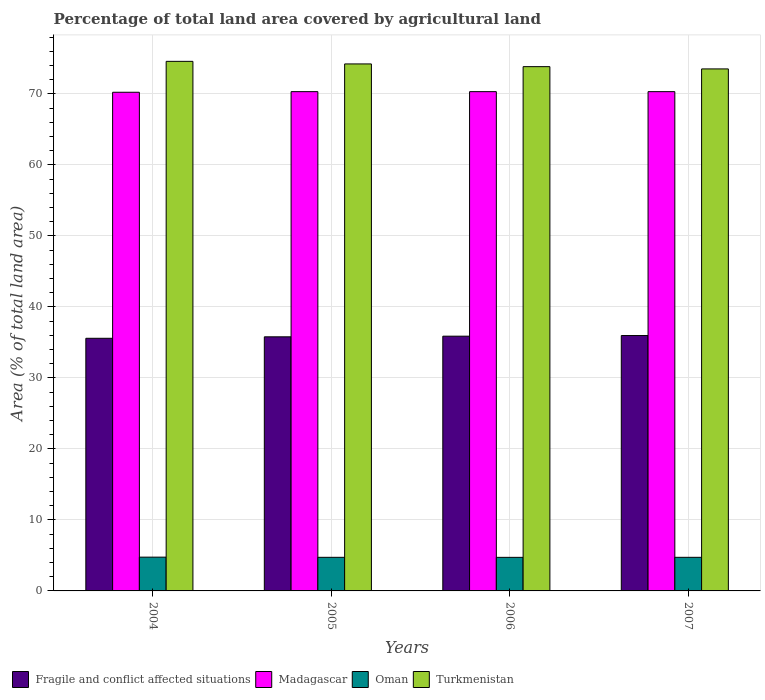How many different coloured bars are there?
Give a very brief answer. 4. How many groups of bars are there?
Keep it short and to the point. 4. Are the number of bars per tick equal to the number of legend labels?
Your response must be concise. Yes. How many bars are there on the 3rd tick from the right?
Offer a very short reply. 4. What is the label of the 2nd group of bars from the left?
Keep it short and to the point. 2005. In how many cases, is the number of bars for a given year not equal to the number of legend labels?
Ensure brevity in your answer.  0. What is the percentage of agricultural land in Oman in 2006?
Offer a terse response. 4.73. Across all years, what is the maximum percentage of agricultural land in Fragile and conflict affected situations?
Keep it short and to the point. 35.97. Across all years, what is the minimum percentage of agricultural land in Fragile and conflict affected situations?
Give a very brief answer. 35.58. In which year was the percentage of agricultural land in Madagascar maximum?
Your answer should be compact. 2005. In which year was the percentage of agricultural land in Turkmenistan minimum?
Provide a short and direct response. 2007. What is the total percentage of agricultural land in Oman in the graph?
Give a very brief answer. 18.95. What is the difference between the percentage of agricultural land in Madagascar in 2006 and that in 2007?
Your answer should be very brief. 0. What is the difference between the percentage of agricultural land in Fragile and conflict affected situations in 2005 and the percentage of agricultural land in Oman in 2004?
Your answer should be very brief. 31.03. What is the average percentage of agricultural land in Madagascar per year?
Offer a terse response. 70.3. In the year 2004, what is the difference between the percentage of agricultural land in Madagascar and percentage of agricultural land in Turkmenistan?
Make the answer very short. -4.35. What is the ratio of the percentage of agricultural land in Oman in 2004 to that in 2005?
Your response must be concise. 1. Is the percentage of agricultural land in Madagascar in 2004 less than that in 2005?
Keep it short and to the point. Yes. Is the difference between the percentage of agricultural land in Madagascar in 2005 and 2007 greater than the difference between the percentage of agricultural land in Turkmenistan in 2005 and 2007?
Your answer should be compact. No. What is the difference between the highest and the second highest percentage of agricultural land in Oman?
Make the answer very short. 0.02. What is the difference between the highest and the lowest percentage of agricultural land in Oman?
Provide a short and direct response. 0.03. In how many years, is the percentage of agricultural land in Madagascar greater than the average percentage of agricultural land in Madagascar taken over all years?
Provide a short and direct response. 3. Is the sum of the percentage of agricultural land in Turkmenistan in 2005 and 2006 greater than the maximum percentage of agricultural land in Madagascar across all years?
Give a very brief answer. Yes. What does the 3rd bar from the left in 2004 represents?
Offer a very short reply. Oman. What does the 3rd bar from the right in 2007 represents?
Your answer should be very brief. Madagascar. How many bars are there?
Keep it short and to the point. 16. Are all the bars in the graph horizontal?
Your answer should be compact. No. How many years are there in the graph?
Ensure brevity in your answer.  4. What is the difference between two consecutive major ticks on the Y-axis?
Ensure brevity in your answer.  10. Are the values on the major ticks of Y-axis written in scientific E-notation?
Make the answer very short. No. How are the legend labels stacked?
Keep it short and to the point. Horizontal. What is the title of the graph?
Give a very brief answer. Percentage of total land area covered by agricultural land. What is the label or title of the Y-axis?
Provide a succinct answer. Area (% of total land area). What is the Area (% of total land area) of Fragile and conflict affected situations in 2004?
Provide a succinct answer. 35.58. What is the Area (% of total land area) in Madagascar in 2004?
Your answer should be very brief. 70.23. What is the Area (% of total land area) of Oman in 2004?
Offer a terse response. 4.76. What is the Area (% of total land area) in Turkmenistan in 2004?
Your response must be concise. 74.59. What is the Area (% of total land area) of Fragile and conflict affected situations in 2005?
Give a very brief answer. 35.79. What is the Area (% of total land area) in Madagascar in 2005?
Keep it short and to the point. 70.32. What is the Area (% of total land area) in Oman in 2005?
Give a very brief answer. 4.73. What is the Area (% of total land area) of Turkmenistan in 2005?
Provide a succinct answer. 74.22. What is the Area (% of total land area) in Fragile and conflict affected situations in 2006?
Provide a short and direct response. 35.88. What is the Area (% of total land area) of Madagascar in 2006?
Make the answer very short. 70.32. What is the Area (% of total land area) of Oman in 2006?
Provide a succinct answer. 4.73. What is the Area (% of total land area) of Turkmenistan in 2006?
Give a very brief answer. 73.84. What is the Area (% of total land area) in Fragile and conflict affected situations in 2007?
Your answer should be compact. 35.97. What is the Area (% of total land area) of Madagascar in 2007?
Your answer should be very brief. 70.32. What is the Area (% of total land area) in Oman in 2007?
Keep it short and to the point. 4.73. What is the Area (% of total land area) in Turkmenistan in 2007?
Make the answer very short. 73.52. Across all years, what is the maximum Area (% of total land area) in Fragile and conflict affected situations?
Offer a very short reply. 35.97. Across all years, what is the maximum Area (% of total land area) of Madagascar?
Ensure brevity in your answer.  70.32. Across all years, what is the maximum Area (% of total land area) in Oman?
Give a very brief answer. 4.76. Across all years, what is the maximum Area (% of total land area) in Turkmenistan?
Keep it short and to the point. 74.59. Across all years, what is the minimum Area (% of total land area) in Fragile and conflict affected situations?
Ensure brevity in your answer.  35.58. Across all years, what is the minimum Area (% of total land area) in Madagascar?
Provide a succinct answer. 70.23. Across all years, what is the minimum Area (% of total land area) of Oman?
Provide a succinct answer. 4.73. Across all years, what is the minimum Area (% of total land area) in Turkmenistan?
Ensure brevity in your answer.  73.52. What is the total Area (% of total land area) in Fragile and conflict affected situations in the graph?
Your answer should be compact. 143.22. What is the total Area (% of total land area) in Madagascar in the graph?
Your answer should be very brief. 281.19. What is the total Area (% of total land area) of Oman in the graph?
Provide a short and direct response. 18.95. What is the total Area (% of total land area) of Turkmenistan in the graph?
Offer a very short reply. 296.17. What is the difference between the Area (% of total land area) in Fragile and conflict affected situations in 2004 and that in 2005?
Provide a short and direct response. -0.21. What is the difference between the Area (% of total land area) of Madagascar in 2004 and that in 2005?
Ensure brevity in your answer.  -0.09. What is the difference between the Area (% of total land area) in Oman in 2004 and that in 2005?
Give a very brief answer. 0.02. What is the difference between the Area (% of total land area) in Turkmenistan in 2004 and that in 2005?
Your response must be concise. 0.36. What is the difference between the Area (% of total land area) in Fragile and conflict affected situations in 2004 and that in 2006?
Provide a short and direct response. -0.3. What is the difference between the Area (% of total land area) in Madagascar in 2004 and that in 2006?
Ensure brevity in your answer.  -0.09. What is the difference between the Area (% of total land area) in Oman in 2004 and that in 2006?
Provide a short and direct response. 0.03. What is the difference between the Area (% of total land area) of Turkmenistan in 2004 and that in 2006?
Keep it short and to the point. 0.74. What is the difference between the Area (% of total land area) in Fragile and conflict affected situations in 2004 and that in 2007?
Your answer should be compact. -0.39. What is the difference between the Area (% of total land area) of Madagascar in 2004 and that in 2007?
Offer a terse response. -0.09. What is the difference between the Area (% of total land area) in Oman in 2004 and that in 2007?
Keep it short and to the point. 0.02. What is the difference between the Area (% of total land area) in Turkmenistan in 2004 and that in 2007?
Keep it short and to the point. 1.06. What is the difference between the Area (% of total land area) in Fragile and conflict affected situations in 2005 and that in 2006?
Offer a terse response. -0.09. What is the difference between the Area (% of total land area) in Oman in 2005 and that in 2006?
Your response must be concise. 0.01. What is the difference between the Area (% of total land area) of Turkmenistan in 2005 and that in 2006?
Offer a terse response. 0.38. What is the difference between the Area (% of total land area) of Fragile and conflict affected situations in 2005 and that in 2007?
Ensure brevity in your answer.  -0.18. What is the difference between the Area (% of total land area) of Turkmenistan in 2005 and that in 2007?
Provide a short and direct response. 0.7. What is the difference between the Area (% of total land area) of Fragile and conflict affected situations in 2006 and that in 2007?
Your answer should be compact. -0.09. What is the difference between the Area (% of total land area) of Oman in 2006 and that in 2007?
Your response must be concise. -0.01. What is the difference between the Area (% of total land area) of Turkmenistan in 2006 and that in 2007?
Give a very brief answer. 0.32. What is the difference between the Area (% of total land area) in Fragile and conflict affected situations in 2004 and the Area (% of total land area) in Madagascar in 2005?
Keep it short and to the point. -34.74. What is the difference between the Area (% of total land area) in Fragile and conflict affected situations in 2004 and the Area (% of total land area) in Oman in 2005?
Provide a succinct answer. 30.85. What is the difference between the Area (% of total land area) in Fragile and conflict affected situations in 2004 and the Area (% of total land area) in Turkmenistan in 2005?
Give a very brief answer. -38.64. What is the difference between the Area (% of total land area) of Madagascar in 2004 and the Area (% of total land area) of Oman in 2005?
Keep it short and to the point. 65.5. What is the difference between the Area (% of total land area) in Madagascar in 2004 and the Area (% of total land area) in Turkmenistan in 2005?
Ensure brevity in your answer.  -3.99. What is the difference between the Area (% of total land area) of Oman in 2004 and the Area (% of total land area) of Turkmenistan in 2005?
Make the answer very short. -69.47. What is the difference between the Area (% of total land area) in Fragile and conflict affected situations in 2004 and the Area (% of total land area) in Madagascar in 2006?
Provide a short and direct response. -34.74. What is the difference between the Area (% of total land area) of Fragile and conflict affected situations in 2004 and the Area (% of total land area) of Oman in 2006?
Your answer should be very brief. 30.85. What is the difference between the Area (% of total land area) of Fragile and conflict affected situations in 2004 and the Area (% of total land area) of Turkmenistan in 2006?
Provide a short and direct response. -38.26. What is the difference between the Area (% of total land area) of Madagascar in 2004 and the Area (% of total land area) of Oman in 2006?
Ensure brevity in your answer.  65.51. What is the difference between the Area (% of total land area) of Madagascar in 2004 and the Area (% of total land area) of Turkmenistan in 2006?
Give a very brief answer. -3.61. What is the difference between the Area (% of total land area) in Oman in 2004 and the Area (% of total land area) in Turkmenistan in 2006?
Ensure brevity in your answer.  -69.08. What is the difference between the Area (% of total land area) of Fragile and conflict affected situations in 2004 and the Area (% of total land area) of Madagascar in 2007?
Offer a very short reply. -34.74. What is the difference between the Area (% of total land area) in Fragile and conflict affected situations in 2004 and the Area (% of total land area) in Oman in 2007?
Ensure brevity in your answer.  30.85. What is the difference between the Area (% of total land area) of Fragile and conflict affected situations in 2004 and the Area (% of total land area) of Turkmenistan in 2007?
Provide a short and direct response. -37.94. What is the difference between the Area (% of total land area) of Madagascar in 2004 and the Area (% of total land area) of Oman in 2007?
Your response must be concise. 65.5. What is the difference between the Area (% of total land area) of Madagascar in 2004 and the Area (% of total land area) of Turkmenistan in 2007?
Your response must be concise. -3.29. What is the difference between the Area (% of total land area) in Oman in 2004 and the Area (% of total land area) in Turkmenistan in 2007?
Your answer should be compact. -68.77. What is the difference between the Area (% of total land area) in Fragile and conflict affected situations in 2005 and the Area (% of total land area) in Madagascar in 2006?
Offer a terse response. -34.53. What is the difference between the Area (% of total land area) in Fragile and conflict affected situations in 2005 and the Area (% of total land area) in Oman in 2006?
Offer a very short reply. 31.06. What is the difference between the Area (% of total land area) in Fragile and conflict affected situations in 2005 and the Area (% of total land area) in Turkmenistan in 2006?
Give a very brief answer. -38.05. What is the difference between the Area (% of total land area) in Madagascar in 2005 and the Area (% of total land area) in Oman in 2006?
Keep it short and to the point. 65.59. What is the difference between the Area (% of total land area) of Madagascar in 2005 and the Area (% of total land area) of Turkmenistan in 2006?
Your answer should be compact. -3.52. What is the difference between the Area (% of total land area) of Oman in 2005 and the Area (% of total land area) of Turkmenistan in 2006?
Ensure brevity in your answer.  -69.11. What is the difference between the Area (% of total land area) in Fragile and conflict affected situations in 2005 and the Area (% of total land area) in Madagascar in 2007?
Provide a short and direct response. -34.53. What is the difference between the Area (% of total land area) in Fragile and conflict affected situations in 2005 and the Area (% of total land area) in Oman in 2007?
Your answer should be compact. 31.05. What is the difference between the Area (% of total land area) of Fragile and conflict affected situations in 2005 and the Area (% of total land area) of Turkmenistan in 2007?
Your answer should be compact. -37.73. What is the difference between the Area (% of total land area) of Madagascar in 2005 and the Area (% of total land area) of Oman in 2007?
Make the answer very short. 65.58. What is the difference between the Area (% of total land area) of Madagascar in 2005 and the Area (% of total land area) of Turkmenistan in 2007?
Provide a succinct answer. -3.2. What is the difference between the Area (% of total land area) in Oman in 2005 and the Area (% of total land area) in Turkmenistan in 2007?
Provide a succinct answer. -68.79. What is the difference between the Area (% of total land area) of Fragile and conflict affected situations in 2006 and the Area (% of total land area) of Madagascar in 2007?
Offer a very short reply. -34.44. What is the difference between the Area (% of total land area) of Fragile and conflict affected situations in 2006 and the Area (% of total land area) of Oman in 2007?
Provide a short and direct response. 31.15. What is the difference between the Area (% of total land area) of Fragile and conflict affected situations in 2006 and the Area (% of total land area) of Turkmenistan in 2007?
Your answer should be compact. -37.64. What is the difference between the Area (% of total land area) of Madagascar in 2006 and the Area (% of total land area) of Oman in 2007?
Provide a short and direct response. 65.58. What is the difference between the Area (% of total land area) of Madagascar in 2006 and the Area (% of total land area) of Turkmenistan in 2007?
Keep it short and to the point. -3.2. What is the difference between the Area (% of total land area) of Oman in 2006 and the Area (% of total land area) of Turkmenistan in 2007?
Your answer should be very brief. -68.79. What is the average Area (% of total land area) of Fragile and conflict affected situations per year?
Ensure brevity in your answer.  35.8. What is the average Area (% of total land area) in Madagascar per year?
Keep it short and to the point. 70.3. What is the average Area (% of total land area) in Oman per year?
Keep it short and to the point. 4.74. What is the average Area (% of total land area) in Turkmenistan per year?
Offer a terse response. 74.04. In the year 2004, what is the difference between the Area (% of total land area) of Fragile and conflict affected situations and Area (% of total land area) of Madagascar?
Your answer should be compact. -34.65. In the year 2004, what is the difference between the Area (% of total land area) of Fragile and conflict affected situations and Area (% of total land area) of Oman?
Provide a short and direct response. 30.82. In the year 2004, what is the difference between the Area (% of total land area) in Fragile and conflict affected situations and Area (% of total land area) in Turkmenistan?
Make the answer very short. -39.01. In the year 2004, what is the difference between the Area (% of total land area) of Madagascar and Area (% of total land area) of Oman?
Keep it short and to the point. 65.48. In the year 2004, what is the difference between the Area (% of total land area) of Madagascar and Area (% of total land area) of Turkmenistan?
Offer a terse response. -4.35. In the year 2004, what is the difference between the Area (% of total land area) of Oman and Area (% of total land area) of Turkmenistan?
Provide a short and direct response. -69.83. In the year 2005, what is the difference between the Area (% of total land area) of Fragile and conflict affected situations and Area (% of total land area) of Madagascar?
Provide a succinct answer. -34.53. In the year 2005, what is the difference between the Area (% of total land area) of Fragile and conflict affected situations and Area (% of total land area) of Oman?
Make the answer very short. 31.05. In the year 2005, what is the difference between the Area (% of total land area) of Fragile and conflict affected situations and Area (% of total land area) of Turkmenistan?
Your answer should be very brief. -38.44. In the year 2005, what is the difference between the Area (% of total land area) of Madagascar and Area (% of total land area) of Oman?
Provide a short and direct response. 65.58. In the year 2005, what is the difference between the Area (% of total land area) of Madagascar and Area (% of total land area) of Turkmenistan?
Provide a succinct answer. -3.91. In the year 2005, what is the difference between the Area (% of total land area) in Oman and Area (% of total land area) in Turkmenistan?
Offer a very short reply. -69.49. In the year 2006, what is the difference between the Area (% of total land area) in Fragile and conflict affected situations and Area (% of total land area) in Madagascar?
Keep it short and to the point. -34.44. In the year 2006, what is the difference between the Area (% of total land area) of Fragile and conflict affected situations and Area (% of total land area) of Oman?
Your answer should be very brief. 31.15. In the year 2006, what is the difference between the Area (% of total land area) of Fragile and conflict affected situations and Area (% of total land area) of Turkmenistan?
Make the answer very short. -37.96. In the year 2006, what is the difference between the Area (% of total land area) of Madagascar and Area (% of total land area) of Oman?
Ensure brevity in your answer.  65.59. In the year 2006, what is the difference between the Area (% of total land area) of Madagascar and Area (% of total land area) of Turkmenistan?
Give a very brief answer. -3.52. In the year 2006, what is the difference between the Area (% of total land area) of Oman and Area (% of total land area) of Turkmenistan?
Offer a terse response. -69.11. In the year 2007, what is the difference between the Area (% of total land area) of Fragile and conflict affected situations and Area (% of total land area) of Madagascar?
Your response must be concise. -34.35. In the year 2007, what is the difference between the Area (% of total land area) of Fragile and conflict affected situations and Area (% of total land area) of Oman?
Offer a very short reply. 31.23. In the year 2007, what is the difference between the Area (% of total land area) in Fragile and conflict affected situations and Area (% of total land area) in Turkmenistan?
Ensure brevity in your answer.  -37.55. In the year 2007, what is the difference between the Area (% of total land area) of Madagascar and Area (% of total land area) of Oman?
Ensure brevity in your answer.  65.58. In the year 2007, what is the difference between the Area (% of total land area) of Madagascar and Area (% of total land area) of Turkmenistan?
Your response must be concise. -3.2. In the year 2007, what is the difference between the Area (% of total land area) of Oman and Area (% of total land area) of Turkmenistan?
Offer a very short reply. -68.79. What is the ratio of the Area (% of total land area) in Madagascar in 2004 to that in 2005?
Keep it short and to the point. 1. What is the ratio of the Area (% of total land area) of Oman in 2004 to that in 2005?
Offer a very short reply. 1. What is the ratio of the Area (% of total land area) of Turkmenistan in 2004 to that in 2005?
Keep it short and to the point. 1. What is the ratio of the Area (% of total land area) in Oman in 2004 to that in 2006?
Give a very brief answer. 1.01. What is the ratio of the Area (% of total land area) of Turkmenistan in 2004 to that in 2006?
Offer a terse response. 1.01. What is the ratio of the Area (% of total land area) in Fragile and conflict affected situations in 2004 to that in 2007?
Your response must be concise. 0.99. What is the ratio of the Area (% of total land area) of Madagascar in 2004 to that in 2007?
Offer a terse response. 1. What is the ratio of the Area (% of total land area) in Oman in 2004 to that in 2007?
Give a very brief answer. 1. What is the ratio of the Area (% of total land area) in Turkmenistan in 2004 to that in 2007?
Offer a terse response. 1.01. What is the ratio of the Area (% of total land area) of Fragile and conflict affected situations in 2005 to that in 2006?
Your answer should be compact. 1. What is the ratio of the Area (% of total land area) in Madagascar in 2005 to that in 2006?
Give a very brief answer. 1. What is the ratio of the Area (% of total land area) of Madagascar in 2005 to that in 2007?
Offer a very short reply. 1. What is the ratio of the Area (% of total land area) of Oman in 2005 to that in 2007?
Make the answer very short. 1. What is the ratio of the Area (% of total land area) of Turkmenistan in 2005 to that in 2007?
Offer a very short reply. 1.01. What is the ratio of the Area (% of total land area) of Fragile and conflict affected situations in 2006 to that in 2007?
Your answer should be compact. 1. What is the ratio of the Area (% of total land area) of Madagascar in 2006 to that in 2007?
Provide a short and direct response. 1. What is the ratio of the Area (% of total land area) in Turkmenistan in 2006 to that in 2007?
Make the answer very short. 1. What is the difference between the highest and the second highest Area (% of total land area) in Fragile and conflict affected situations?
Provide a succinct answer. 0.09. What is the difference between the highest and the second highest Area (% of total land area) in Oman?
Ensure brevity in your answer.  0.02. What is the difference between the highest and the second highest Area (% of total land area) of Turkmenistan?
Keep it short and to the point. 0.36. What is the difference between the highest and the lowest Area (% of total land area) in Fragile and conflict affected situations?
Your answer should be compact. 0.39. What is the difference between the highest and the lowest Area (% of total land area) of Madagascar?
Keep it short and to the point. 0.09. What is the difference between the highest and the lowest Area (% of total land area) in Oman?
Offer a terse response. 0.03. What is the difference between the highest and the lowest Area (% of total land area) in Turkmenistan?
Your response must be concise. 1.06. 